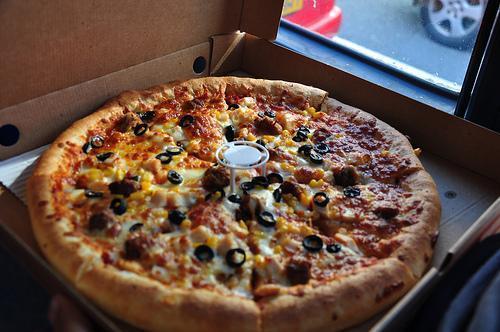How many wheels do you see?
Give a very brief answer. 1. 